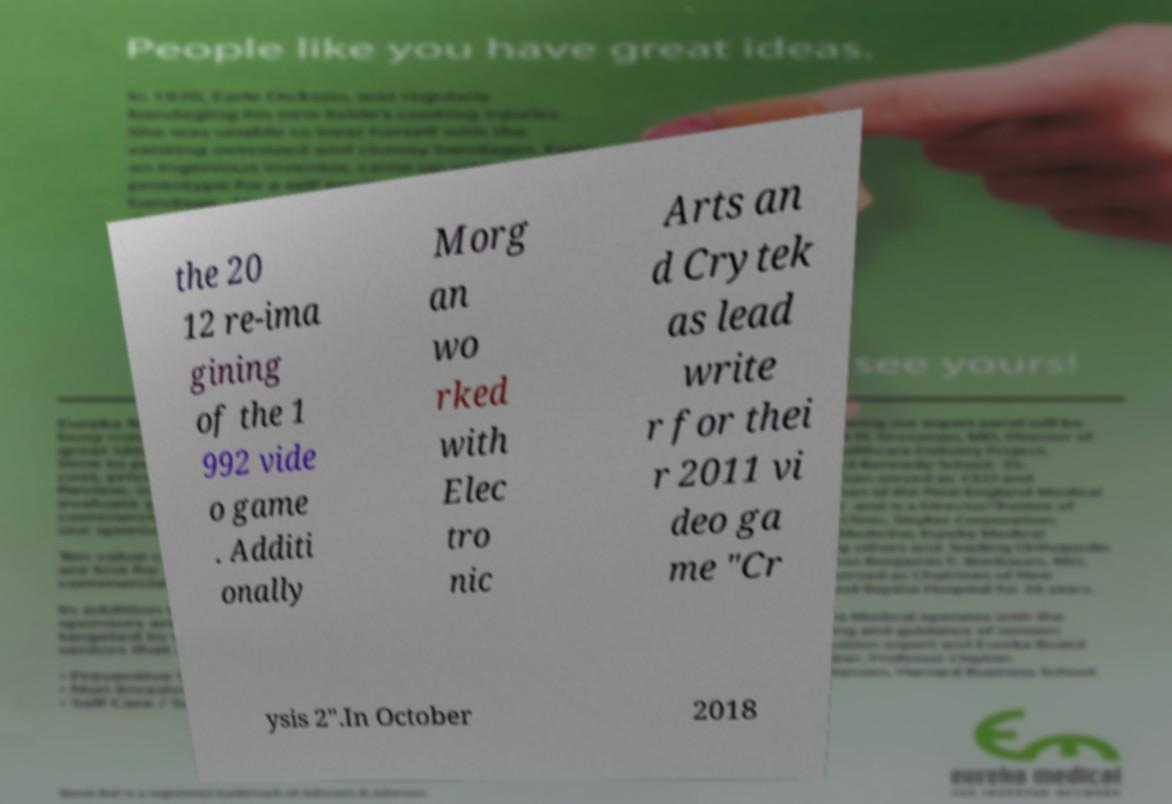Please read and relay the text visible in this image. What does it say? the 20 12 re-ima gining of the 1 992 vide o game . Additi onally Morg an wo rked with Elec tro nic Arts an d Crytek as lead write r for thei r 2011 vi deo ga me "Cr ysis 2".In October 2018 